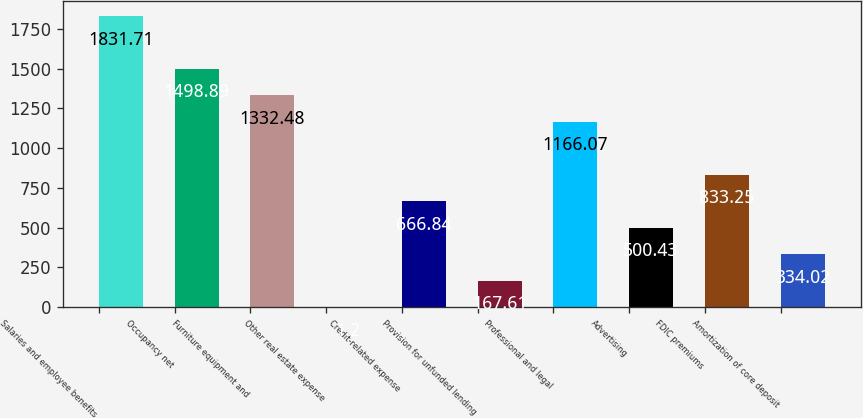Convert chart to OTSL. <chart><loc_0><loc_0><loc_500><loc_500><bar_chart><fcel>Salaries and employee benefits<fcel>Occupancy net<fcel>Furniture equipment and<fcel>Other real estate expense<fcel>Credit-related expense<fcel>Provision for unfunded lending<fcel>Professional and legal<fcel>Advertising<fcel>FDIC premiums<fcel>Amortization of core deposit<nl><fcel>1831.71<fcel>1498.89<fcel>1332.48<fcel>1.2<fcel>666.84<fcel>167.61<fcel>1166.07<fcel>500.43<fcel>833.25<fcel>334.02<nl></chart> 